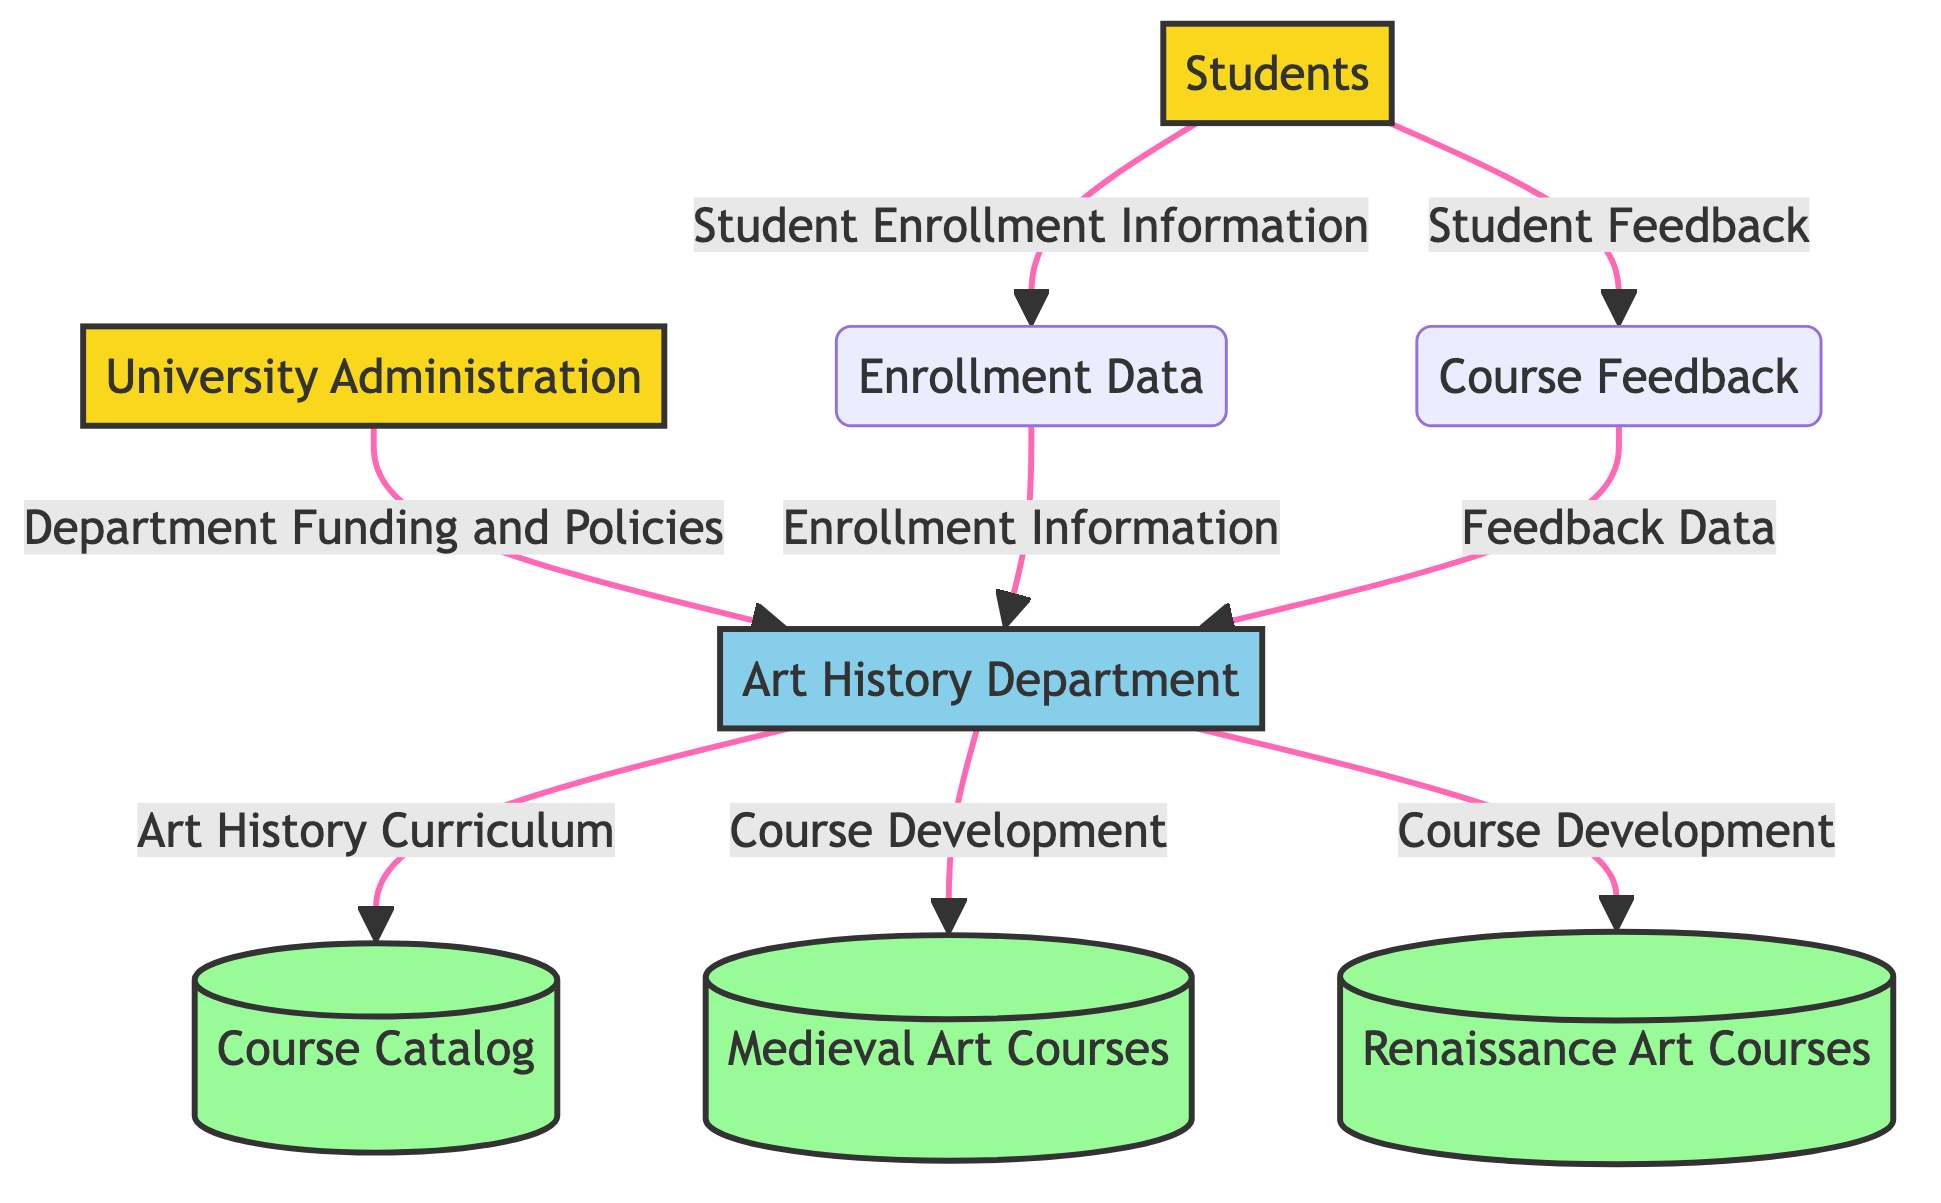What is the external entity that funds the Art History Department? The diagram indicates that the University Administration provides funding and policies to the Art History Department. So, by identifying the direct flow from "University Administration" to "Art History Department," we confirm that the University Administration is the external entity responsible for the funding.
Answer: University Administration How many data stores are present in the diagram? The entities labeled as data stores include Course Catalog, Medieval Art Courses, and Renaissance Art Courses, which totals to three data stores in the diagram.
Answer: 3 What type of information do students provide to the system regarding courses? According to the diagram, students provide "Student Feedback" and this connects from the Students to the Course Feedback node, showing their input regarding courses.
Answer: Student Feedback Which department is responsible for curriculum changes related to Art History? The Art History Department, represented as a process in the diagram, is clearly responsible for the Art History curriculum, indicated by the data flow from the Art History Department to the Course Catalog.
Answer: Art History Department What is the flow of data from students to the Art History Department? Students flow two distinct pieces of data to the Art History Department: "Student Enrollment Information" and "Student Feedback." These flows respectively guide enrollment and course evaluations to the Art History Department.
Answer: Student Enrollment Information and Student Feedback What process does the Art History Department use for course development? The Art History Department engages in "Course Development" for both Medieval Art Courses and Renaissance Art Courses, as shown by the separate flows from the Art History Department to these respective data stores.
Answer: Course Development What data flows between Enrollment Data and the Art History Department? The flow of "Enrollment Information" moves from Enrollment Data to the Art History Department, indicating that enrollment statistics and details are communicated to the department for further action or analysis.
Answer: Enrollment Information Does the diagram show any interaction for feedback data? Yes, there is a data flow labeled "Feedback Data" that proceeds from Course Feedback back to the Art History Department, indicating that feedback data collected from students is passed on to the department for review and action.
Answer: Feedback Data 